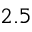Convert formula to latex. <formula><loc_0><loc_0><loc_500><loc_500>2 . 5</formula> 